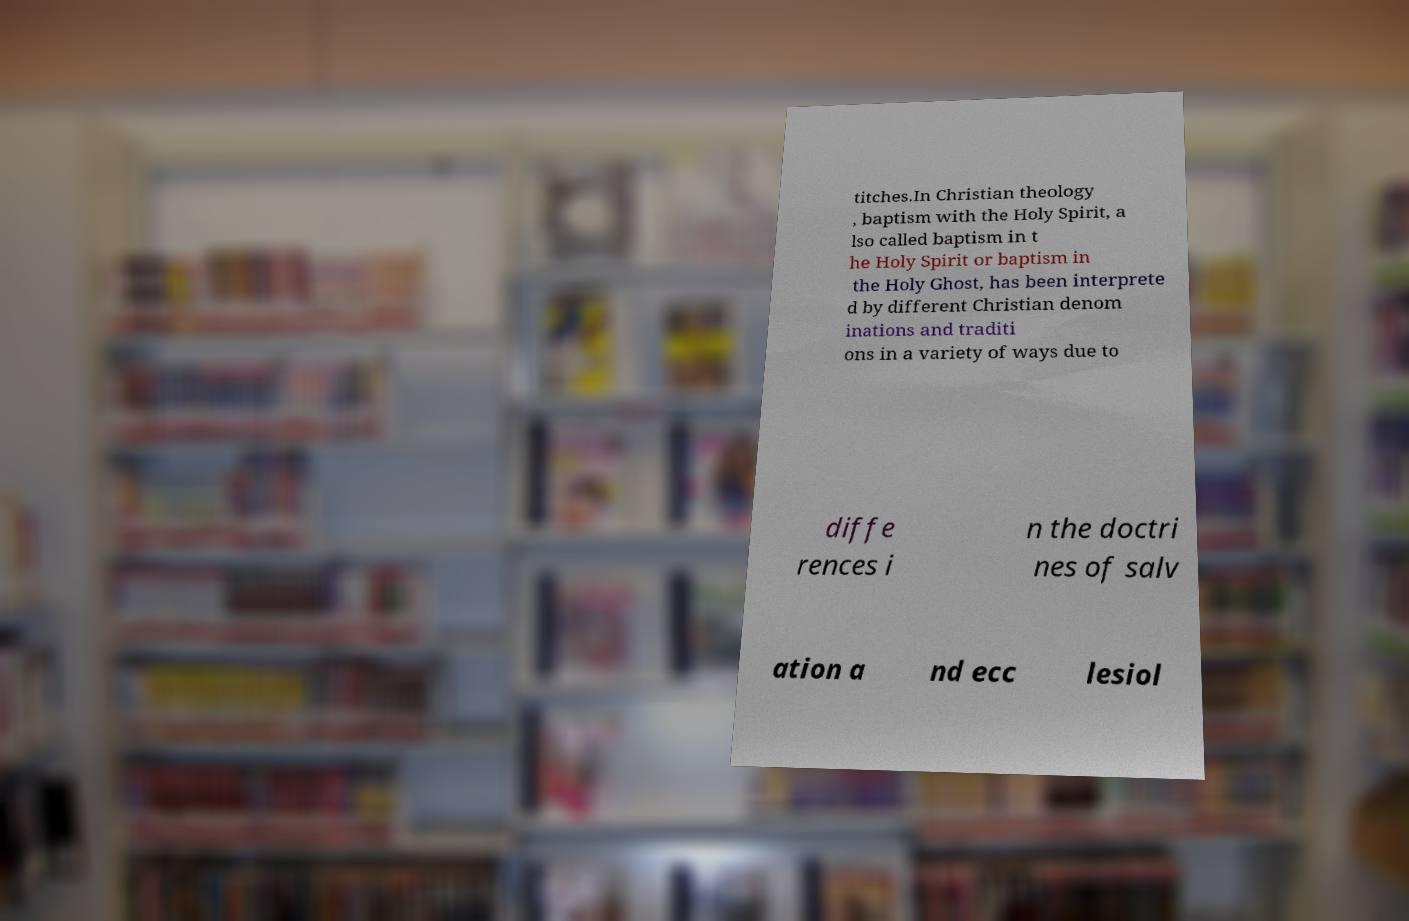Can you accurately transcribe the text from the provided image for me? titches.In Christian theology , baptism with the Holy Spirit, a lso called baptism in t he Holy Spirit or baptism in the Holy Ghost, has been interprete d by different Christian denom inations and traditi ons in a variety of ways due to diffe rences i n the doctri nes of salv ation a nd ecc lesiol 